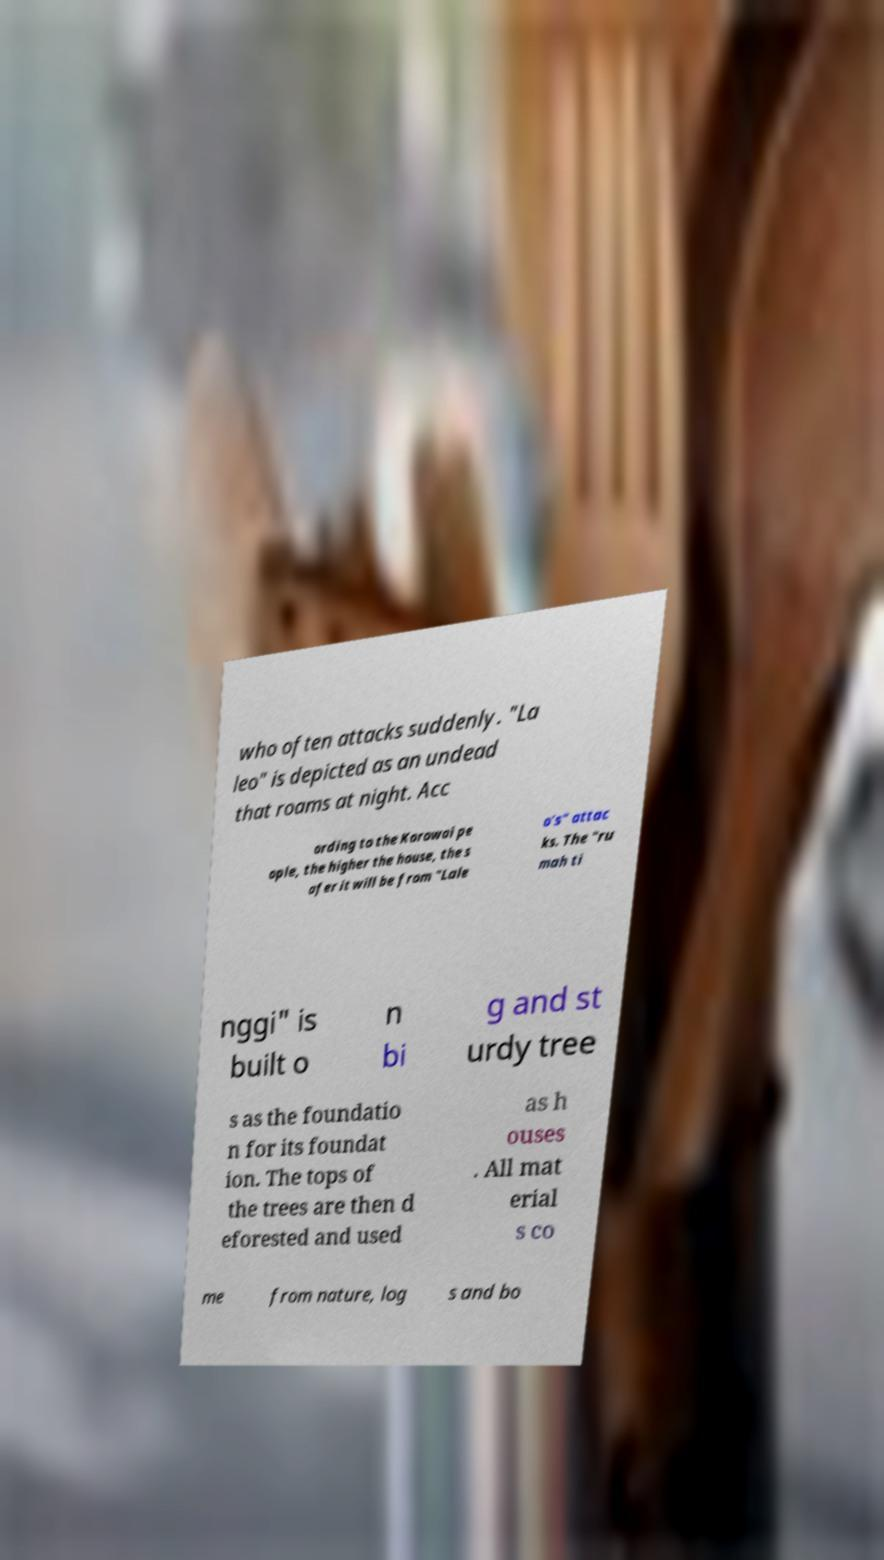For documentation purposes, I need the text within this image transcribed. Could you provide that? who often attacks suddenly. "La leo" is depicted as an undead that roams at night. Acc ording to the Korowai pe ople, the higher the house, the s afer it will be from "Lale o's" attac ks. The "ru mah ti nggi" is built o n bi g and st urdy tree s as the foundatio n for its foundat ion. The tops of the trees are then d eforested and used as h ouses . All mat erial s co me from nature, log s and bo 